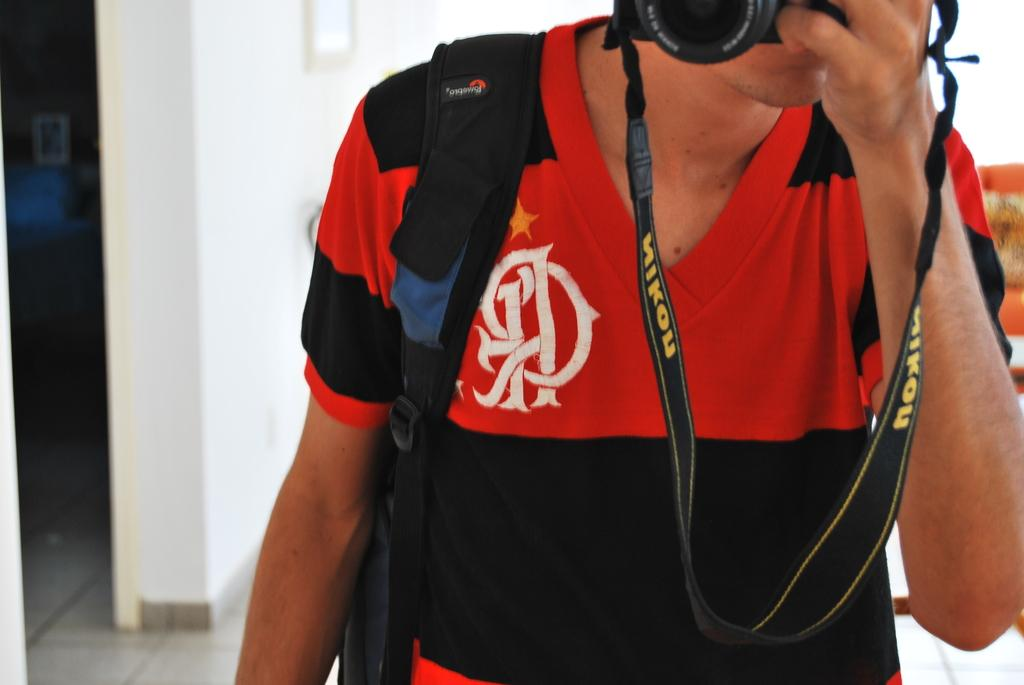<image>
Summarize the visual content of the image. A gentleman is looking through a camera that has a strap that reads Nikon. 